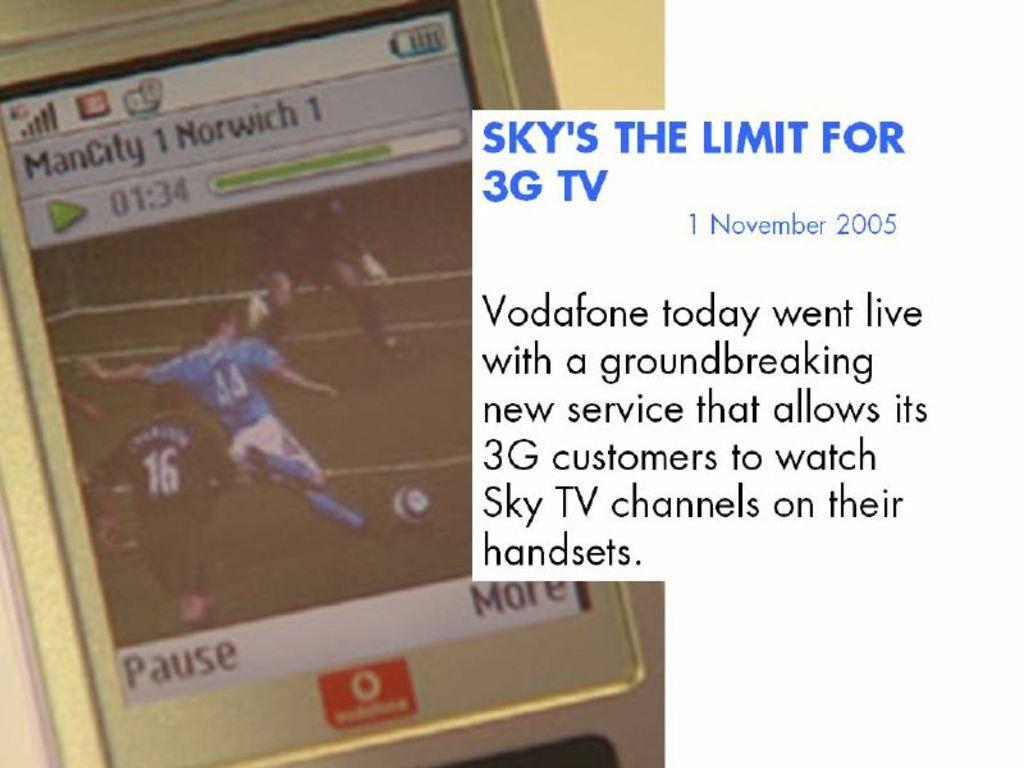<image>
Write a terse but informative summary of the picture. A picture of a cellphone screen that says ManCity 1 Norwich 1. 